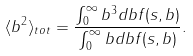Convert formula to latex. <formula><loc_0><loc_0><loc_500><loc_500>\langle b ^ { 2 } \rangle _ { t o t } = \frac { \int _ { 0 } ^ { \infty } b ^ { 3 } d b f ( s , b ) } { \int _ { 0 } ^ { \infty } b d b f ( s , b ) } .</formula> 